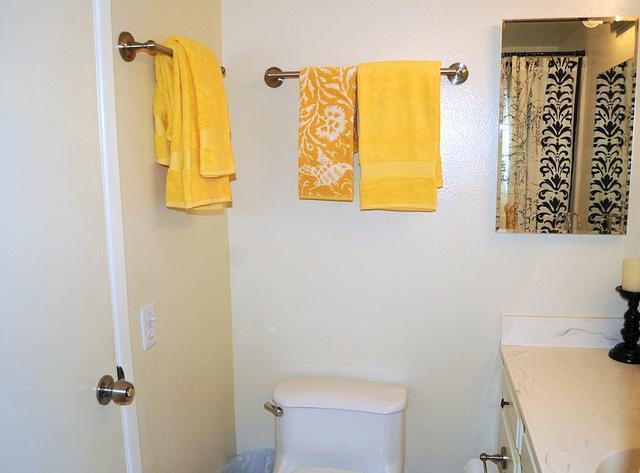How many people are in the dugout?
Give a very brief answer. 0. 